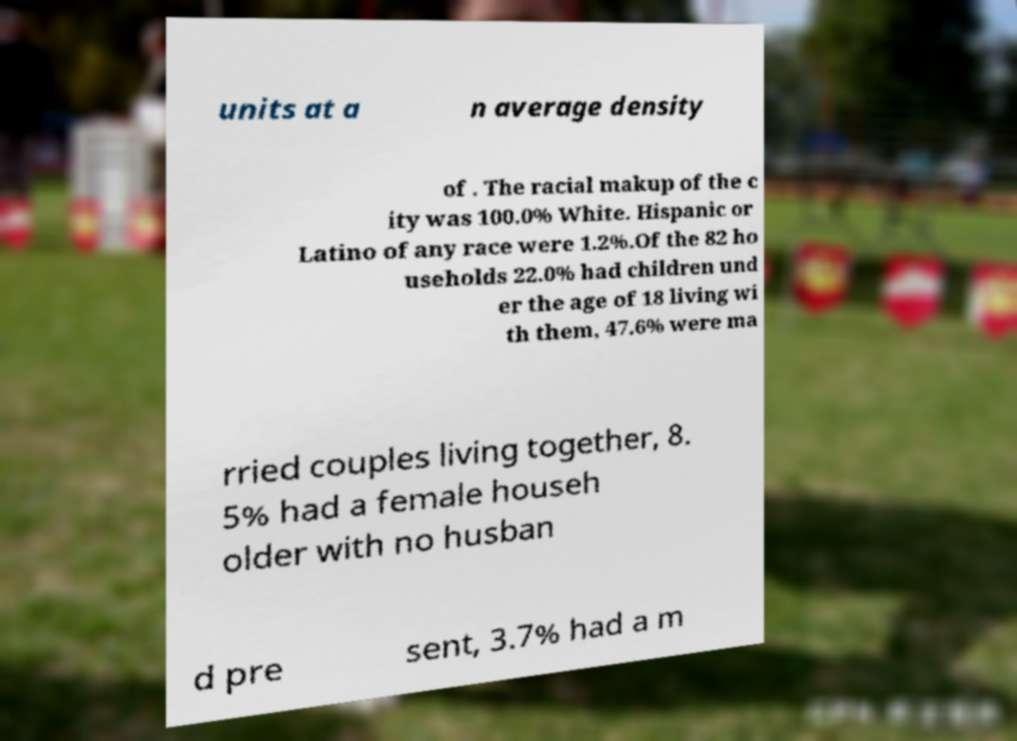Please read and relay the text visible in this image. What does it say? units at a n average density of . The racial makup of the c ity was 100.0% White. Hispanic or Latino of any race were 1.2%.Of the 82 ho useholds 22.0% had children und er the age of 18 living wi th them, 47.6% were ma rried couples living together, 8. 5% had a female househ older with no husban d pre sent, 3.7% had a m 